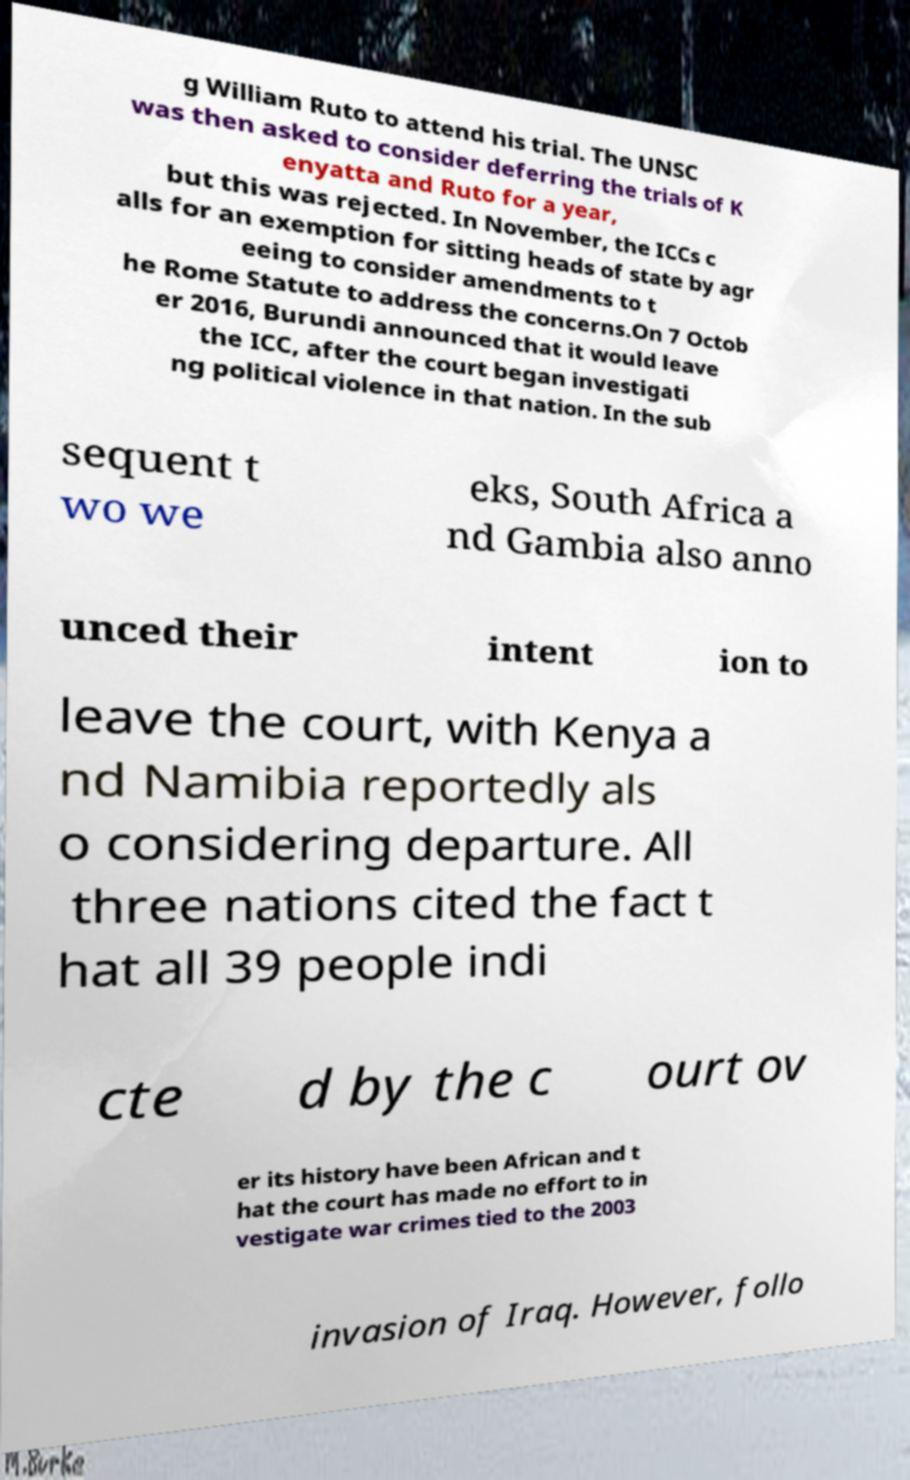Could you extract and type out the text from this image? g William Ruto to attend his trial. The UNSC was then asked to consider deferring the trials of K enyatta and Ruto for a year, but this was rejected. In November, the ICCs c alls for an exemption for sitting heads of state by agr eeing to consider amendments to t he Rome Statute to address the concerns.On 7 Octob er 2016, Burundi announced that it would leave the ICC, after the court began investigati ng political violence in that nation. In the sub sequent t wo we eks, South Africa a nd Gambia also anno unced their intent ion to leave the court, with Kenya a nd Namibia reportedly als o considering departure. All three nations cited the fact t hat all 39 people indi cte d by the c ourt ov er its history have been African and t hat the court has made no effort to in vestigate war crimes tied to the 2003 invasion of Iraq. However, follo 